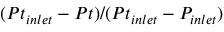Convert formula to latex. <formula><loc_0><loc_0><loc_500><loc_500>( P t _ { i n l e t } - P t ) / ( P t _ { i n l e t } - P _ { i n l e t } )</formula> 